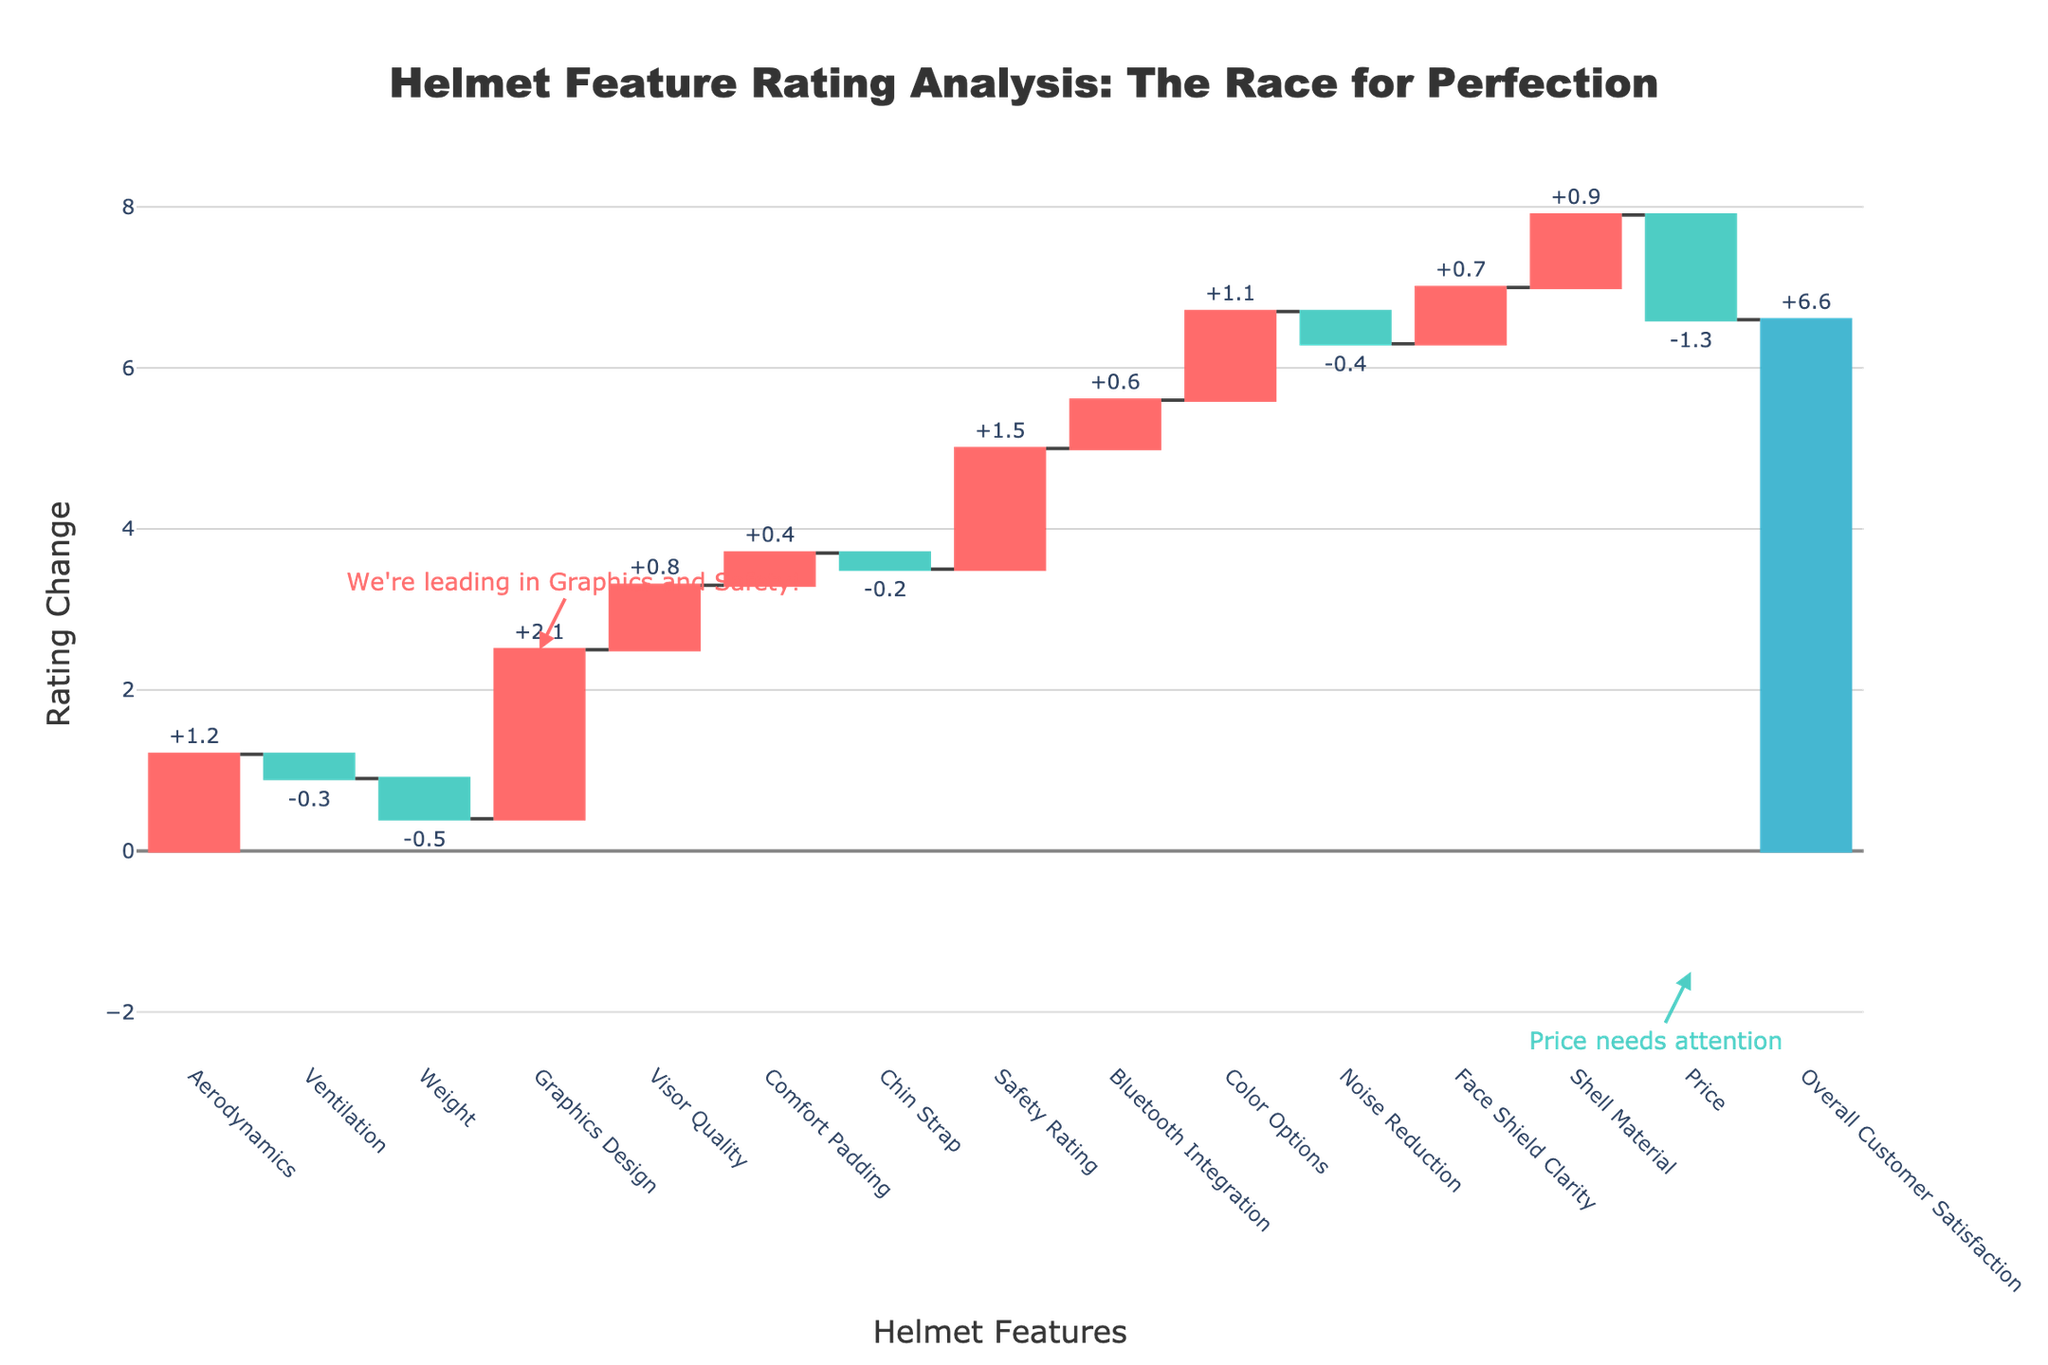What's the title of the chart? The title of the chart is written at the top, which is typical for plots. It's located above the graphical representation of the data.
Answer: Helmet Feature Rating Analysis: The Race for Perfection How many features have a negative rating change? Count the number of downward segments in the waterfall chart, shown in a different color (e.g., decrease markers are often colored differently).
Answer: 5 Which feature shows the highest positive rating change? Identify the segment with the largest upward bar in the waterfall chart, which is often highlighted prominently.
Answer: Graphics Design What is the total overall customer satisfaction change? Look for the total change bar at the end of the waterfall which usually summarizes the net effect of all individual changes.
Answer: +6.6 Which feature has the biggest negative rating change and what is that change? Identify the feature with the largest downward segment in the chart and note the corresponding value provided next to the segment.
Answer: Price, -1.3 How much did aerodynamics contribute to the overall rating change? Find the segment labeled "Aerodynamics" and check the rating change value associated with it.
Answer: +1.2 Compare the rating changes of Ventilation and Weight. Which one has a larger negative impact? Identify the segments corresponding to Ventilation and Weight, compare their rating changes (both are negative), and determine which is larger in absolute value.
Answer: Weight What is the sum of the rating changes for Visor Quality and Bluetooth Integration? Add the rating changes of Visor Quality (+0.8) and Bluetooth Integration (+0.6).
Answer: +1.4 What is the difference in rating change between Graphics Design and Ventilation? Subtract the rating change of Ventilation (-0.3) from the rating change of Graphics Design (+2.1).
Answer: 2.4 If you only focus on the safety-related features (Safety Rating and Shell Material), what is their combined contribution to the overall rating? Add the rating changes of Safety Rating (+1.5) and Shell Material (+0.9).
Answer: +2.4 